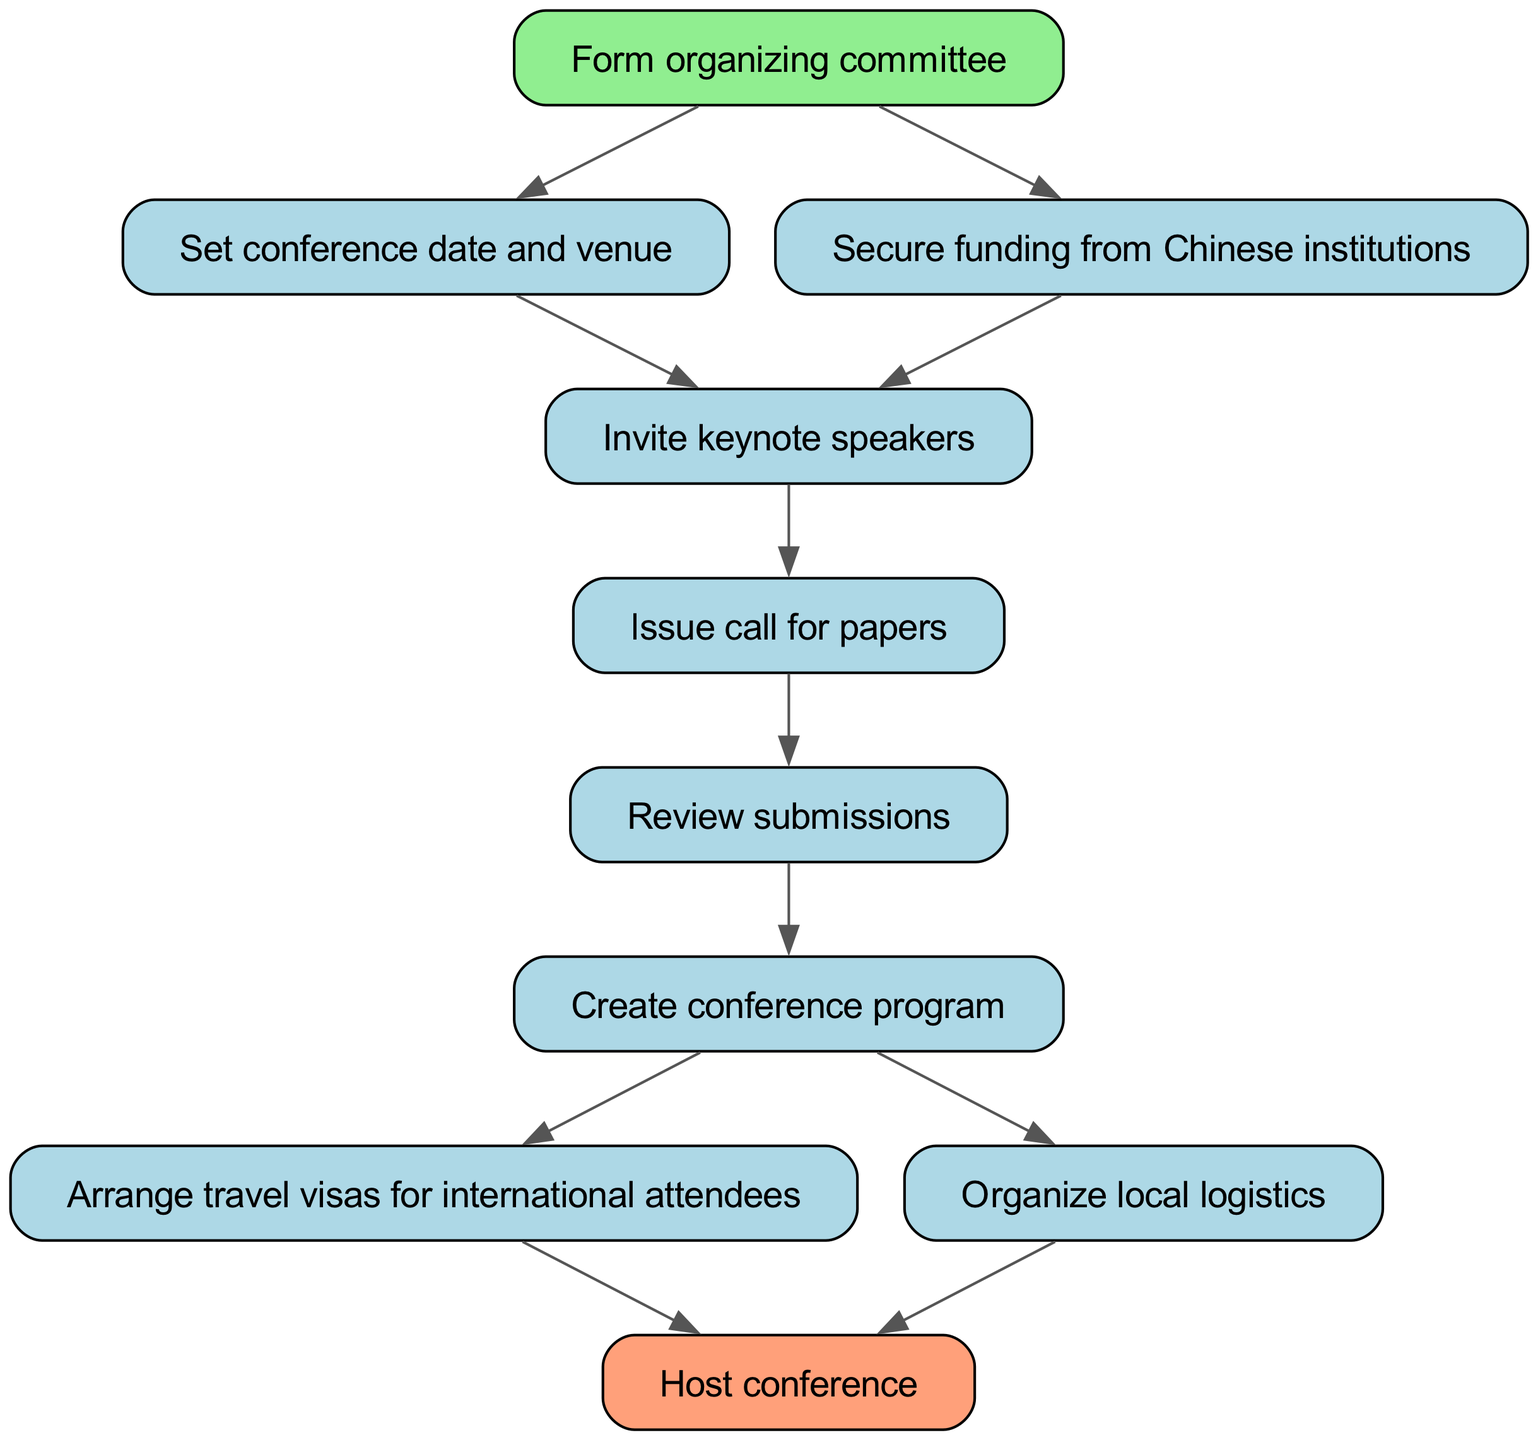What is the first step in the diagram? The first step is represented by the node "Form organizing committee," which is the starting point of the flow chart.
Answer: Form organizing committee How many nodes are in the diagram? To determine the number of nodes, we count each unique step represented; there are a total of 10 nodes in this flow chart.
Answer: 10 What are the last two steps before hosting the conference? The last two steps before reaching the node "Host conference" are "Arrange travel visas for international attendees" and "Organize local logistics," both of which lead to the final step.
Answer: Arrange travel visas for international attendees, Organize local logistics What step occurs after securing funding? After "Secure funding from Chinese institutions," the next step is "Invite keynote speakers," which continues the process toward organizing the conference.
Answer: Invite keynote speakers Which step directly follows issuing the call for papers? Following the step "Issue call for papers," the next step is "Review submissions," which is essential for selecting papers for the conference program.
Answer: Review submissions What is the relationship between the steps "Set conference date and venue" and "Invite keynote speakers"? These two steps are connected sequentially; after "Set conference date and venue" is completed, it leads directly to the next step "Invite keynote speakers," indicating an order of tasks.
Answer: Sequential connection If all steps are followed sequentially, what is the final outcome represented in the diagram? The final outcome, represented by the last node "Host conference," illustrates the culmination of all previous planning and organizing efforts laid out in the diagram.
Answer: Host conference How many different paths can be taken from the "Form organizing committee" to the "Host conference"? The flow chart allows for different paths through the nodes; counting all possible routes reveals 3 different paths leading to the final step.
Answer: 3 What is the significance of the colors used in the diagram, especially for the first and last steps? The colors highlight the importance of starting and ending points; the "Form organizing committee" node is colored light green indicating initiation, while "Host conference" is light salmon to signify completion.
Answer: Initiation and completion significance 